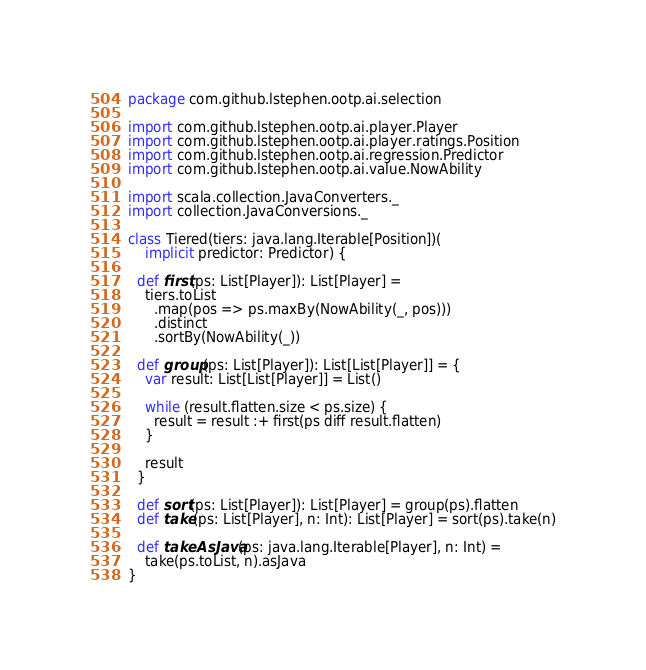<code> <loc_0><loc_0><loc_500><loc_500><_Scala_>package com.github.lstephen.ootp.ai.selection

import com.github.lstephen.ootp.ai.player.Player
import com.github.lstephen.ootp.ai.player.ratings.Position
import com.github.lstephen.ootp.ai.regression.Predictor
import com.github.lstephen.ootp.ai.value.NowAbility

import scala.collection.JavaConverters._
import collection.JavaConversions._

class Tiered(tiers: java.lang.Iterable[Position])(
    implicit predictor: Predictor) {

  def first(ps: List[Player]): List[Player] =
    tiers.toList
      .map(pos => ps.maxBy(NowAbility(_, pos)))
      .distinct
      .sortBy(NowAbility(_))

  def group(ps: List[Player]): List[List[Player]] = {
    var result: List[List[Player]] = List()

    while (result.flatten.size < ps.size) {
      result = result :+ first(ps diff result.flatten)
    }

    result
  }

  def sort(ps: List[Player]): List[Player] = group(ps).flatten
  def take(ps: List[Player], n: Int): List[Player] = sort(ps).take(n)

  def takeAsJava(ps: java.lang.Iterable[Player], n: Int) =
    take(ps.toList, n).asJava
}
</code> 